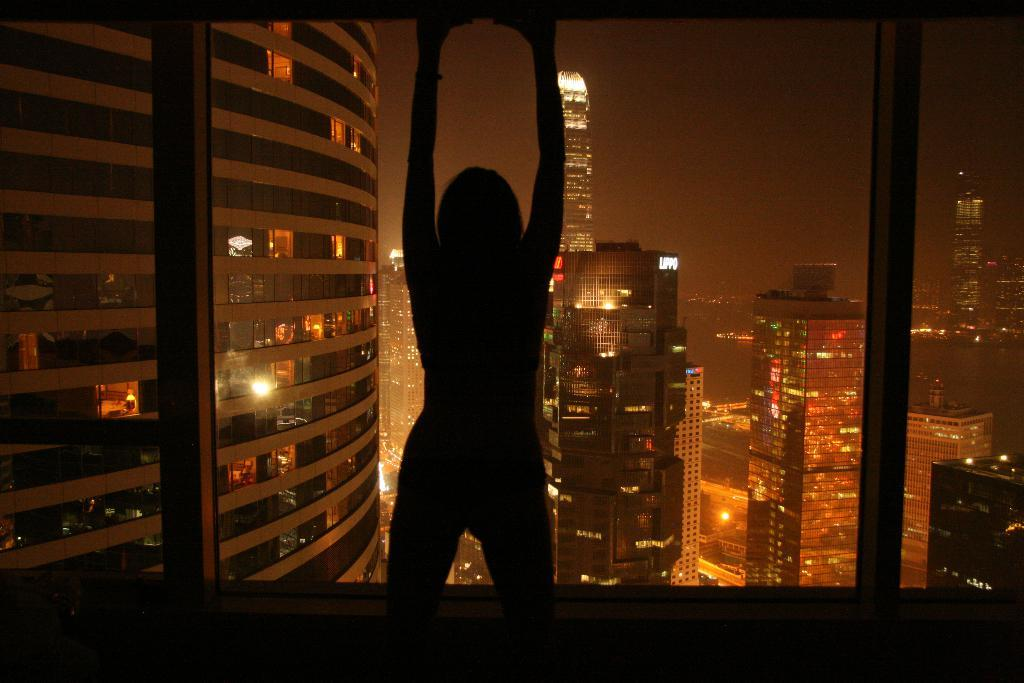What is the main subject of the image? There is a person standing in the image. What can be seen in the background of the image? There are buildings in the background of the image. What type of calculator is the person using in the image? There is no calculator present in the image. Is the person in the image being attacked by anyone or anything? There is no indication of an attack or any danger in the image. 